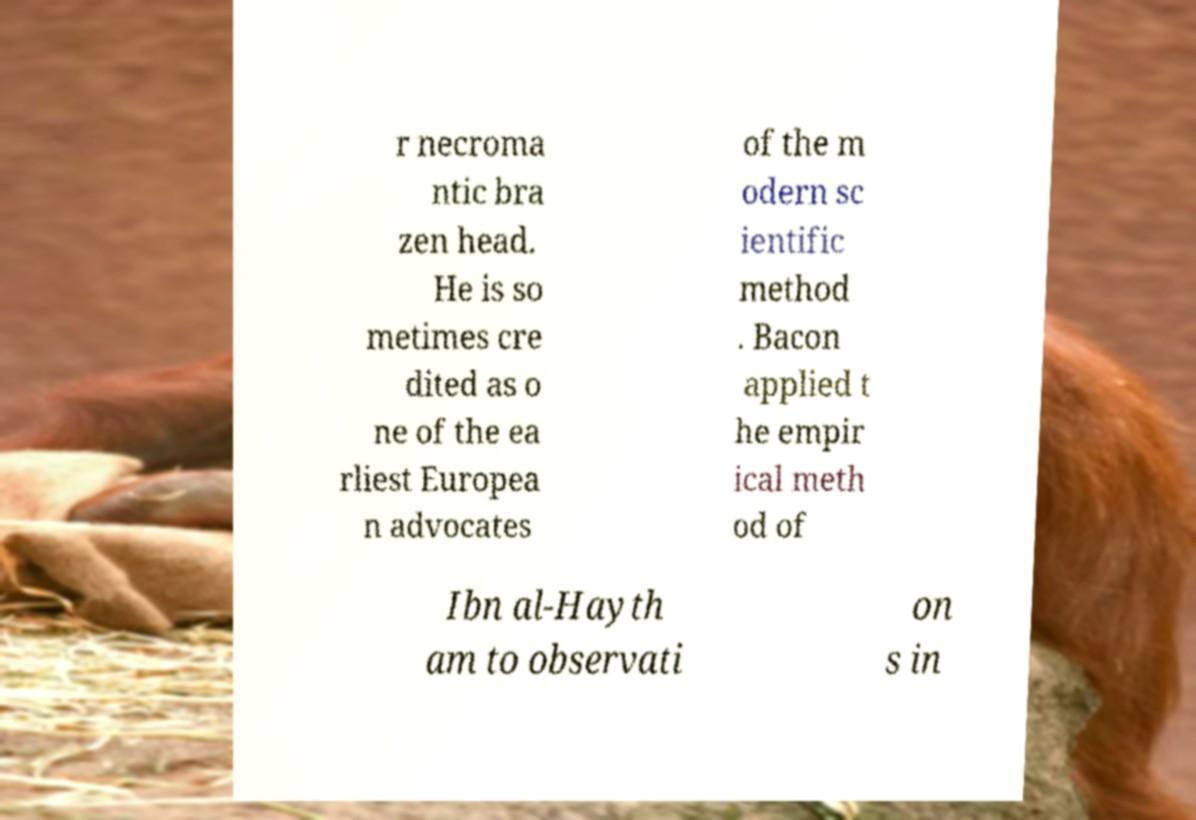There's text embedded in this image that I need extracted. Can you transcribe it verbatim? r necroma ntic bra zen head. He is so metimes cre dited as o ne of the ea rliest Europea n advocates of the m odern sc ientific method . Bacon applied t he empir ical meth od of Ibn al-Hayth am to observati on s in 